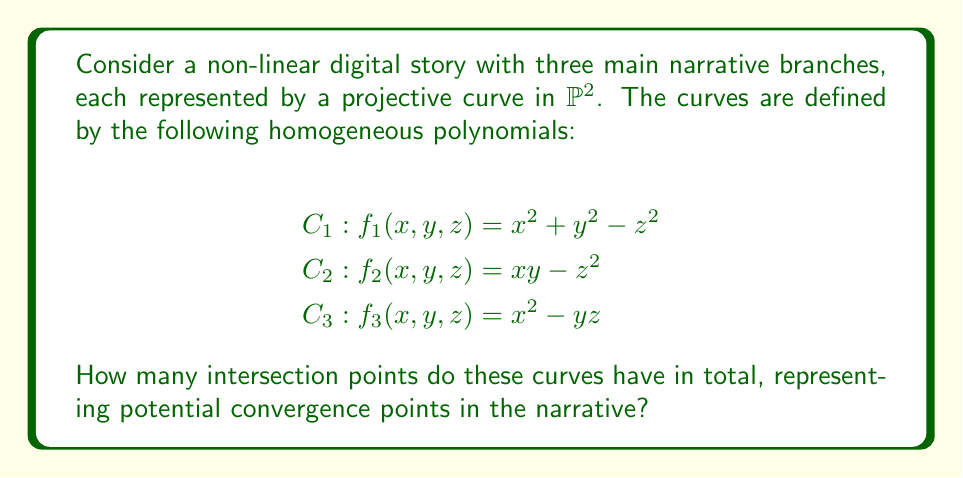Can you solve this math problem? To solve this problem, we'll follow these steps:

1) First, we need to find the intersection points of each pair of curves:
   - $C_1 \cap C_2$
   - $C_1 \cap C_3$
   - $C_2 \cap C_3$

2) For $C_1 \cap C_2$:
   Substitute $z^2 = xy$ from $C_2$ into $C_1$:
   $x^2 + y^2 - xy = 0$
   This is a homogeneous equation of degree 2, which generally has 2 solutions in $\mathbb{P}^2$.

3) For $C_1 \cap C_3$:
   Substitute $x^2 = yz$ from $C_3$ into $C_1$:
   $yz + y^2 - z^2 = 0$
   This is also a homogeneous equation of degree 2, with 2 solutions in $\mathbb{P}^2$.

4) For $C_2 \cap C_3$:
   From $C_2$: $xy = z^2$
   From $C_3$: $x^2 = yz$
   Substituting: $x(x^2/y) = z^2$
   $x^3 = y z^2$
   This is a homogeneous equation of degree 3, which generally has 3 solutions in $\mathbb{P}^2$.

5) By Bézout's theorem, the total number of intersection points (counting multiplicity) for three curves of degrees 2, 2, and 2 in $\mathbb{P}^2$ is $2 \cdot 2 \cdot 2 = 8$.

6) We've found 2 + 2 + 3 = 7 intersection points. The remaining point must be the point where all three curves intersect simultaneously.

Therefore, the total number of intersection points, representing potential convergence points in the narrative, is 8.
Answer: 8 intersection points 